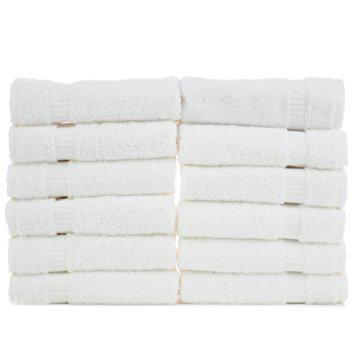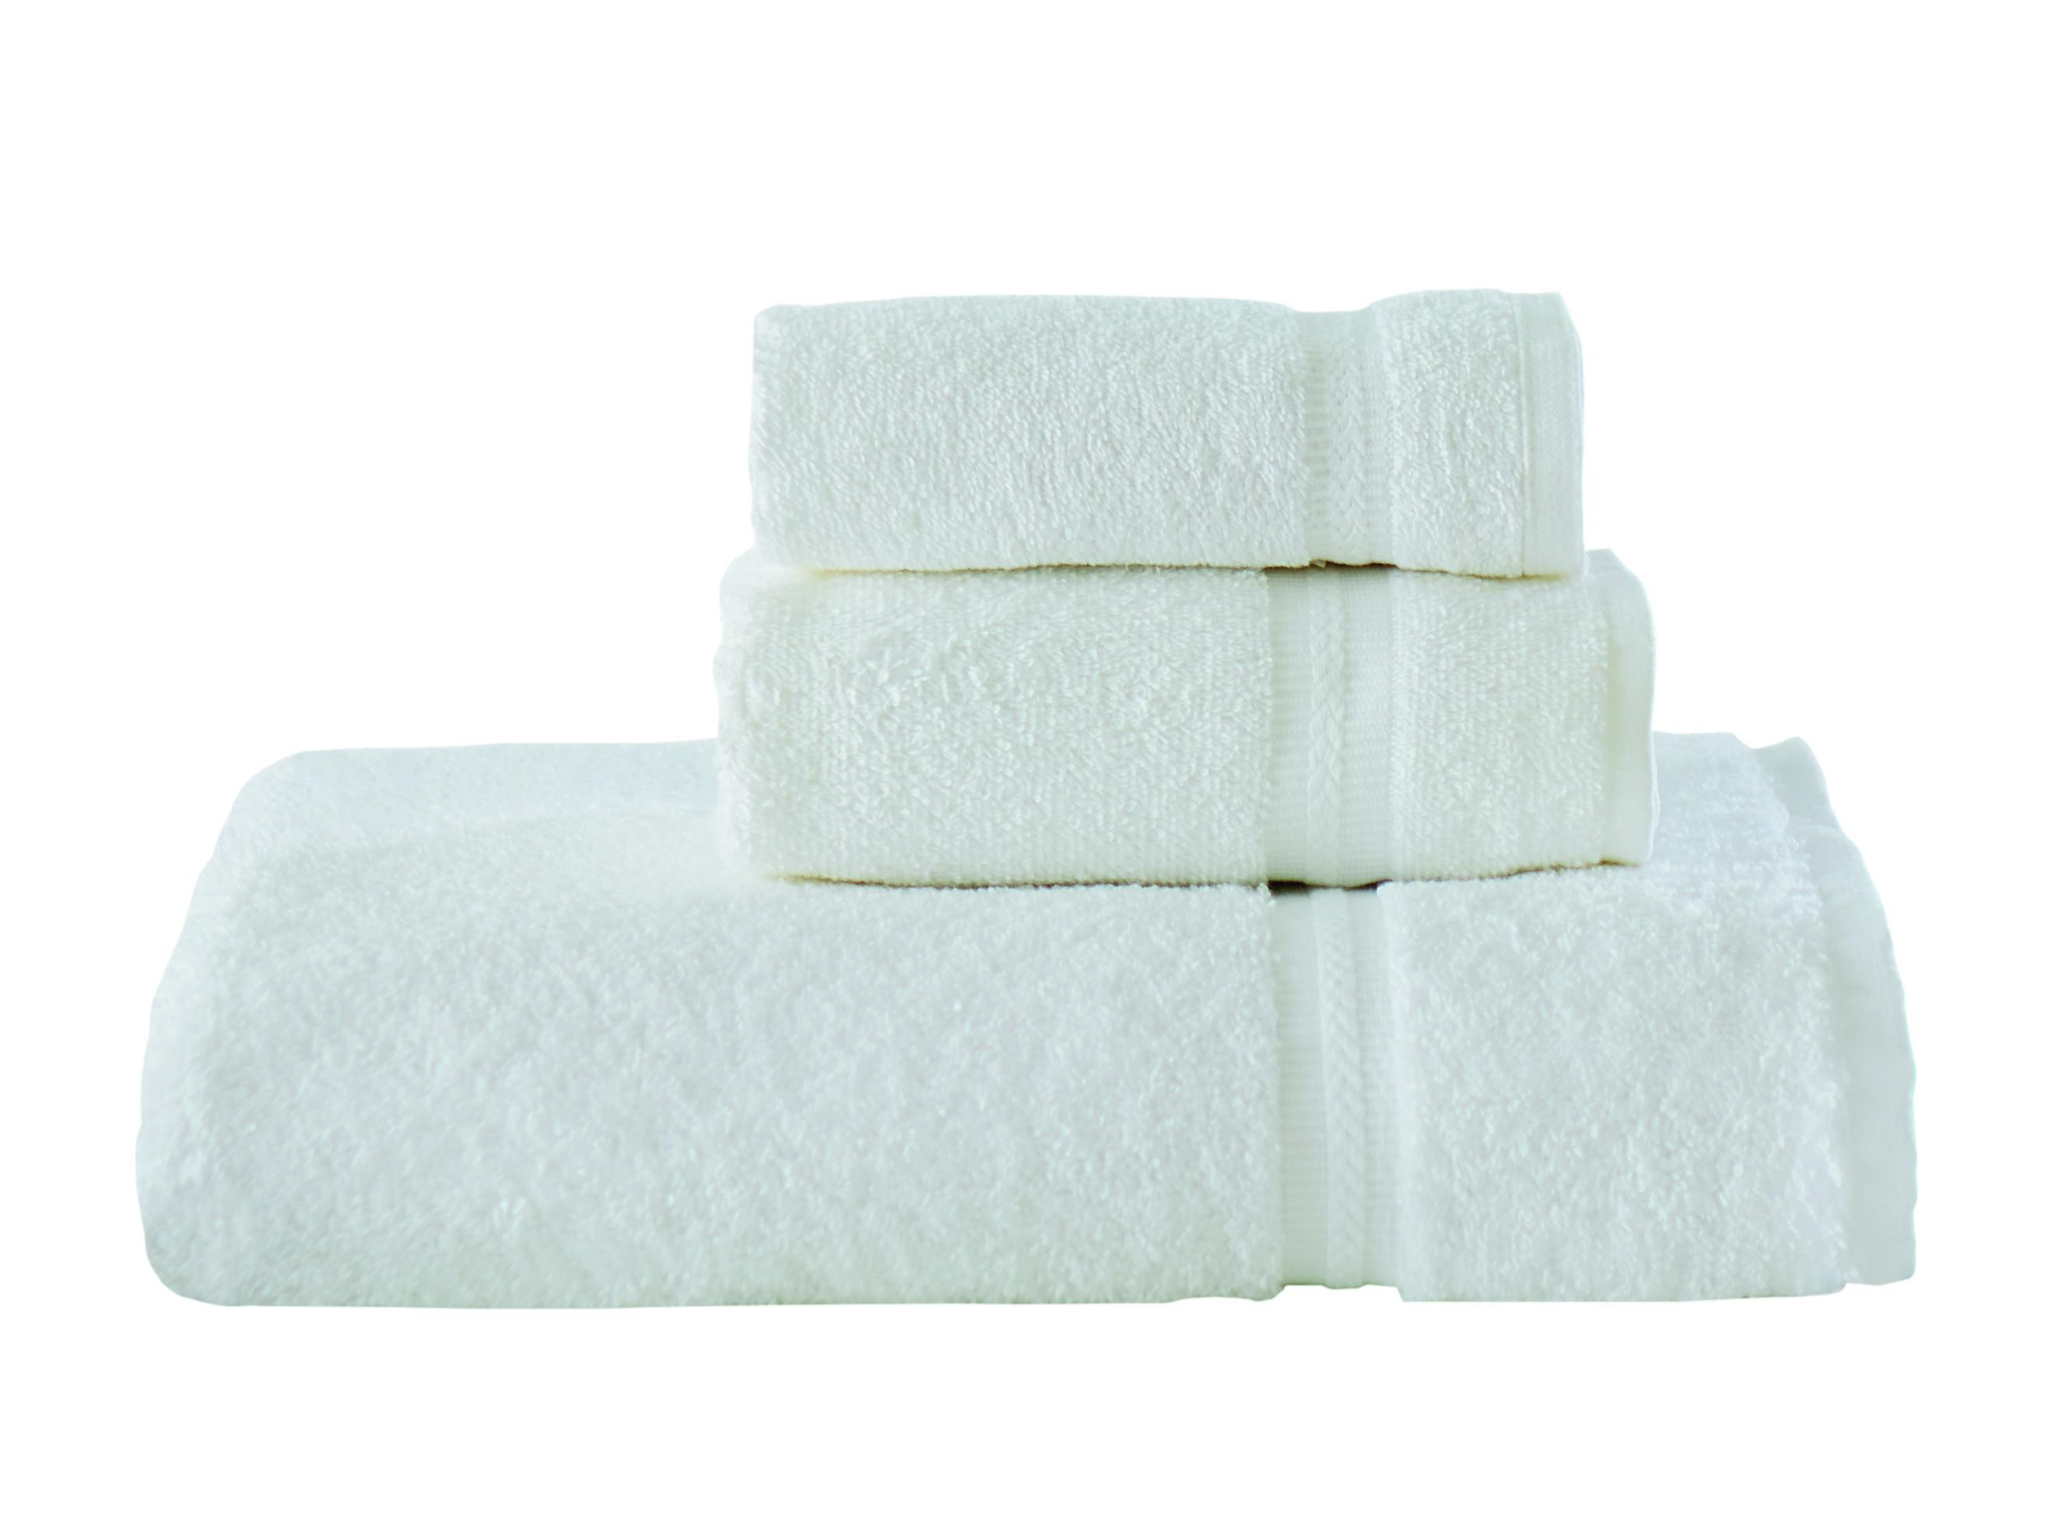The first image is the image on the left, the second image is the image on the right. Evaluate the accuracy of this statement regarding the images: "There are at most 6 towels shown.". Is it true? Answer yes or no. No. The first image is the image on the left, the second image is the image on the right. Given the left and right images, does the statement "Exactly two large white folded towels are shown in one image." hold true? Answer yes or no. No. 